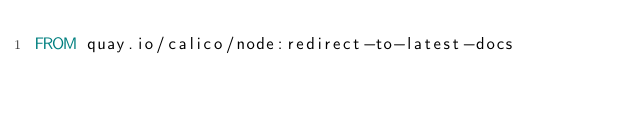Convert code to text. <code><loc_0><loc_0><loc_500><loc_500><_Dockerfile_>FROM quay.io/calico/node:redirect-to-latest-docs
</code> 